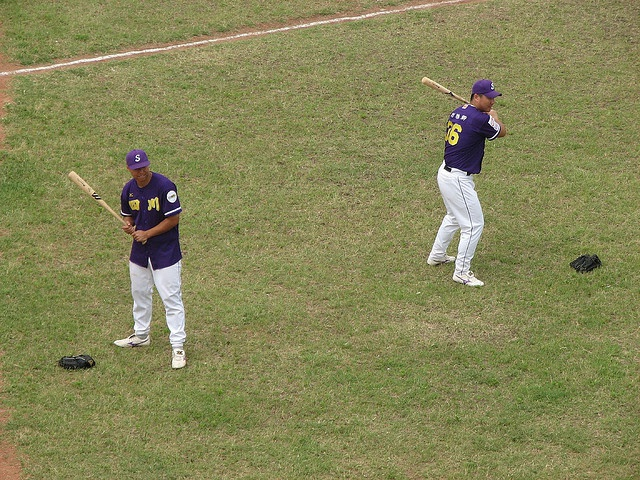Describe the objects in this image and their specific colors. I can see people in darkgreen, lightgray, black, olive, and navy tones, people in darkgreen, lightgray, black, navy, and darkgray tones, baseball bat in darkgreen, tan, and olive tones, baseball glove in darkgreen, black, gray, and olive tones, and baseball glove in darkgreen, black, gray, and darkgray tones in this image. 